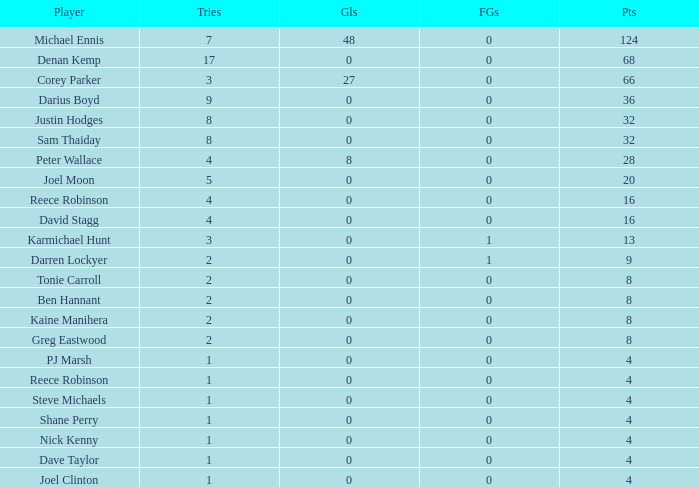How many points did the player with 2 tries and more than 0 field goals have? 9.0. 